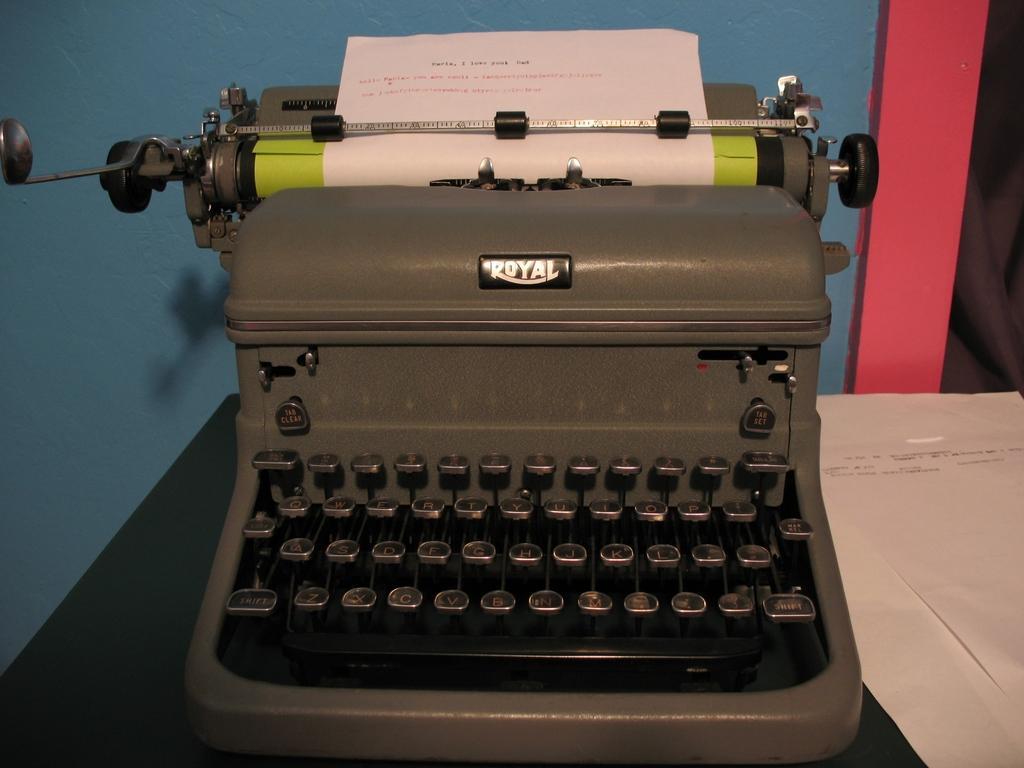Could you give a brief overview of what you see in this image? This picture is clicked inside. In the center there is a typewriter placed on the top of the table and there are some papers placed on the top of the table. In the background we can see a blue color wall. 